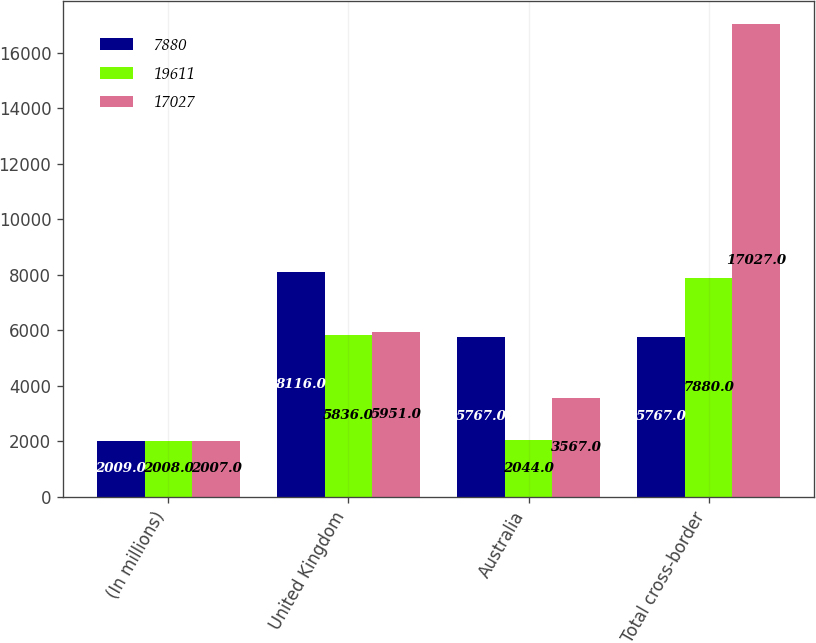Convert chart to OTSL. <chart><loc_0><loc_0><loc_500><loc_500><stacked_bar_chart><ecel><fcel>(In millions)<fcel>United Kingdom<fcel>Australia<fcel>Total cross-border<nl><fcel>7880<fcel>2009<fcel>8116<fcel>5767<fcel>5767<nl><fcel>19611<fcel>2008<fcel>5836<fcel>2044<fcel>7880<nl><fcel>17027<fcel>2007<fcel>5951<fcel>3567<fcel>17027<nl></chart> 